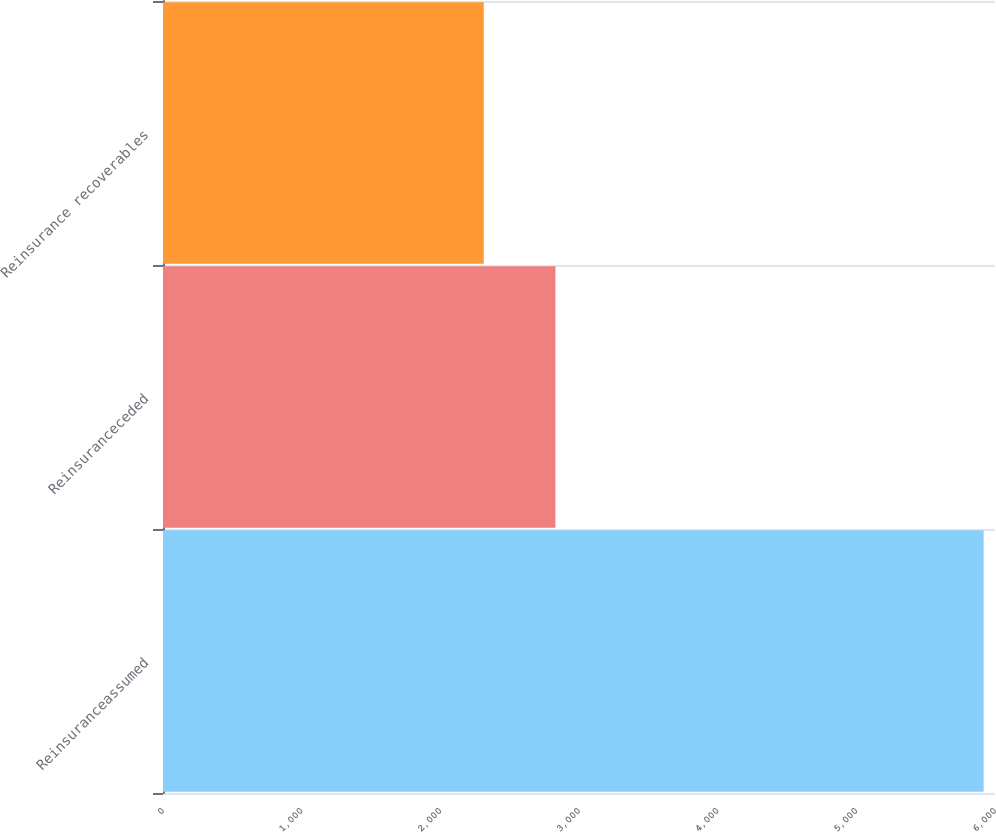Convert chart to OTSL. <chart><loc_0><loc_0><loc_500><loc_500><bar_chart><fcel>Reinsuranceassumed<fcel>Reinsuranceceded<fcel>Reinsurance recoverables<nl><fcel>5918<fcel>2830<fcel>2313<nl></chart> 